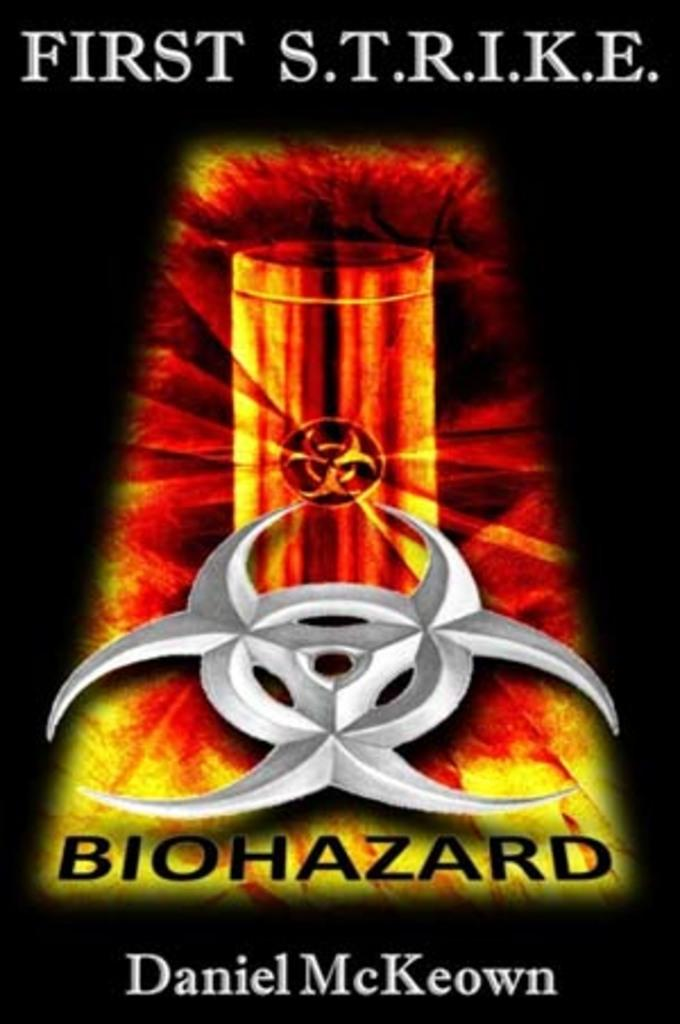<image>
Give a short and clear explanation of the subsequent image. an advertisement with the name Daniel McKeown at the bottom 